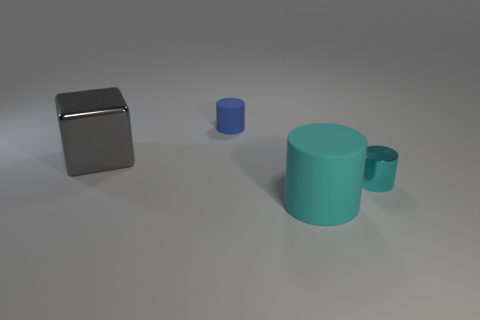Add 1 small green rubber objects. How many objects exist? 5 Subtract all cubes. How many objects are left? 3 Subtract 0 gray cylinders. How many objects are left? 4 Subtract all small yellow matte cylinders. Subtract all metallic cubes. How many objects are left? 3 Add 3 big cyan rubber cylinders. How many big cyan rubber cylinders are left? 4 Add 1 metallic things. How many metallic things exist? 3 